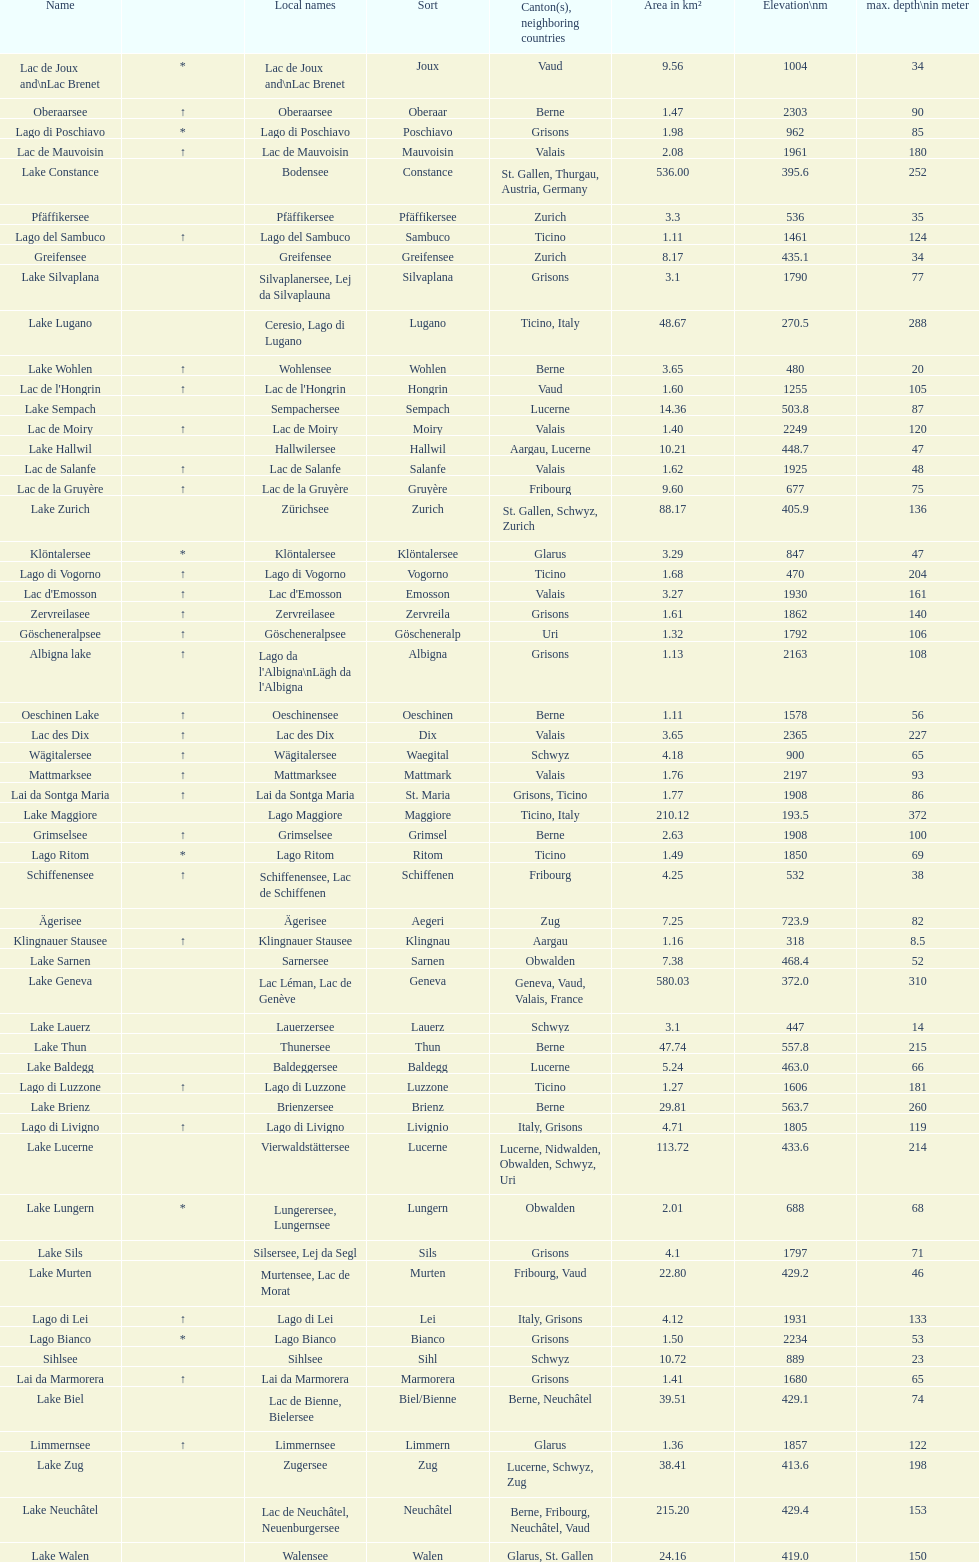What is the deepest lake? Lake Maggiore. 